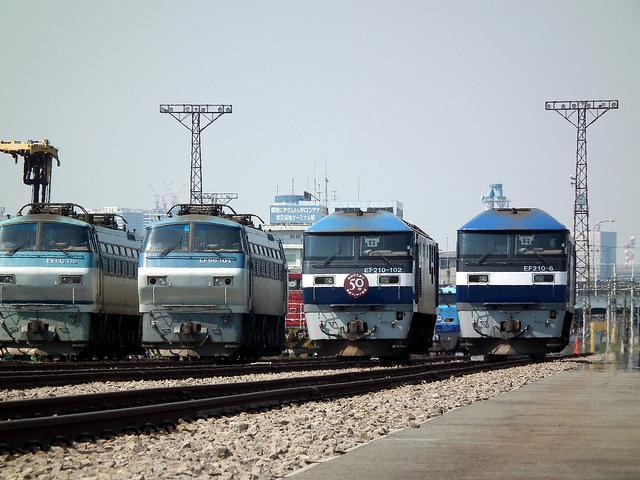How many trains are in the picture?
Give a very brief answer. 4. How many trains are there?
Give a very brief answer. 4. 